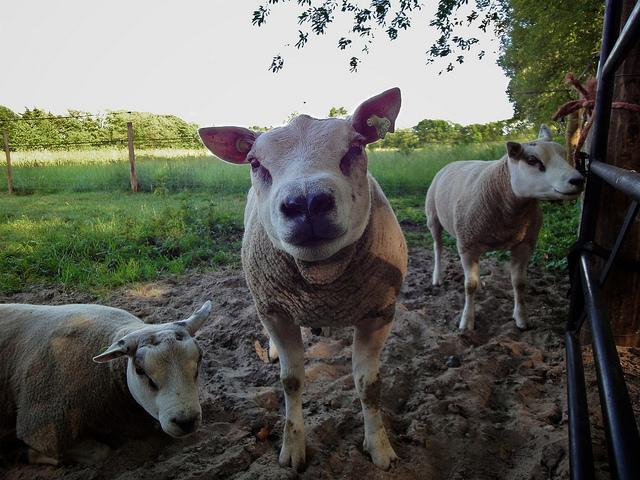How many weird looking sheeps are standing on top of the dirt pile? three 